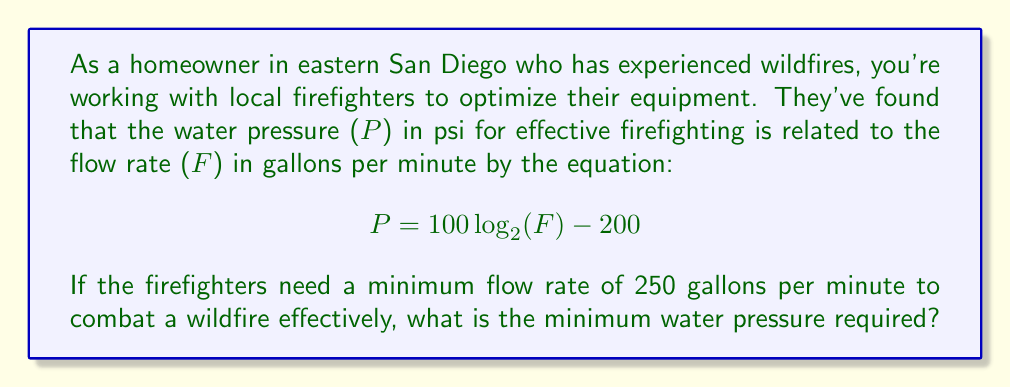Show me your answer to this math problem. To solve this problem, we'll use the given logarithmic equation and follow these steps:

1) We're given the equation: $P = 100 \log_{2}(F) - 200$

2) We need to find P when F = 250 gpm.

3) Let's substitute F = 250 into the equation:

   $P = 100 \log_{2}(250) - 200$

4) Now we need to evaluate $\log_{2}(250)$. We can use the change of base formula to calculate this using common logarithms:

   $\log_{2}(250) = \frac{\log(250)}{\log(2)}$

5) Using a calculator:
   $\log(250) \approx 2.3979$
   $\log(2) \approx 0.3010$

   $\frac{2.3979}{0.3010} \approx 7.9665$

6) Now we can substitute this value back into our equation:

   $P = 100(7.9665) - 200$

7) Simplify:
   $P = 796.65 - 200 = 596.65$

8) Round to the nearest whole number, as pressure gauges typically don't measure to two decimal places.

Therefore, the minimum water pressure required is approximately 597 psi.
Answer: 597 psi 